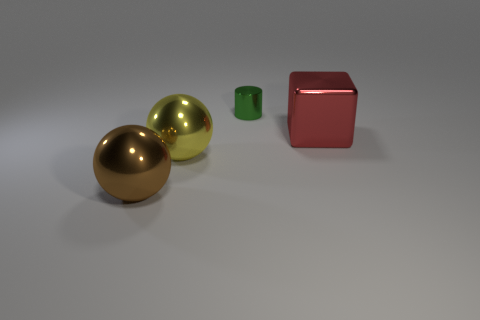Is there any other thing that is the same size as the cylinder?
Offer a very short reply. No. What is the material of the large object that is on the right side of the yellow sphere?
Your answer should be compact. Metal. Is the green object the same shape as the yellow metal object?
Keep it short and to the point. No. Is there anything else that is the same color as the small cylinder?
Offer a terse response. No. What color is the other shiny object that is the same shape as the yellow metallic thing?
Offer a terse response. Brown. Are there more big brown balls that are in front of the small metallic cylinder than tiny cylinders?
Offer a very short reply. No. There is a object behind the metal cube; what color is it?
Your answer should be very brief. Green. Do the red block and the yellow object have the same size?
Provide a succinct answer. Yes. What is the size of the brown object?
Provide a short and direct response. Large. Are there more green metal things than large balls?
Provide a short and direct response. No. 